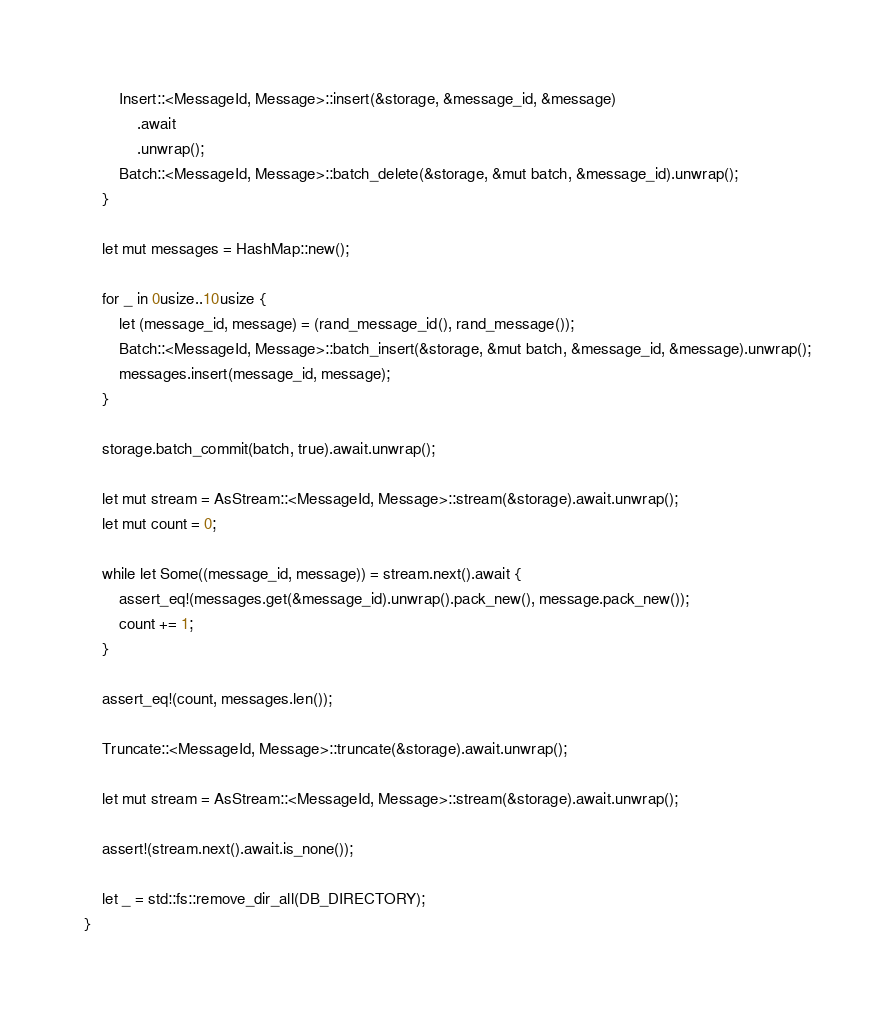Convert code to text. <code><loc_0><loc_0><loc_500><loc_500><_Rust_>        Insert::<MessageId, Message>::insert(&storage, &message_id, &message)
            .await
            .unwrap();
        Batch::<MessageId, Message>::batch_delete(&storage, &mut batch, &message_id).unwrap();
    }

    let mut messages = HashMap::new();

    for _ in 0usize..10usize {
        let (message_id, message) = (rand_message_id(), rand_message());
        Batch::<MessageId, Message>::batch_insert(&storage, &mut batch, &message_id, &message).unwrap();
        messages.insert(message_id, message);
    }

    storage.batch_commit(batch, true).await.unwrap();

    let mut stream = AsStream::<MessageId, Message>::stream(&storage).await.unwrap();
    let mut count = 0;

    while let Some((message_id, message)) = stream.next().await {
        assert_eq!(messages.get(&message_id).unwrap().pack_new(), message.pack_new());
        count += 1;
    }

    assert_eq!(count, messages.len());

    Truncate::<MessageId, Message>::truncate(&storage).await.unwrap();

    let mut stream = AsStream::<MessageId, Message>::stream(&storage).await.unwrap();

    assert!(stream.next().await.is_none());

    let _ = std::fs::remove_dir_all(DB_DIRECTORY);
}
</code> 